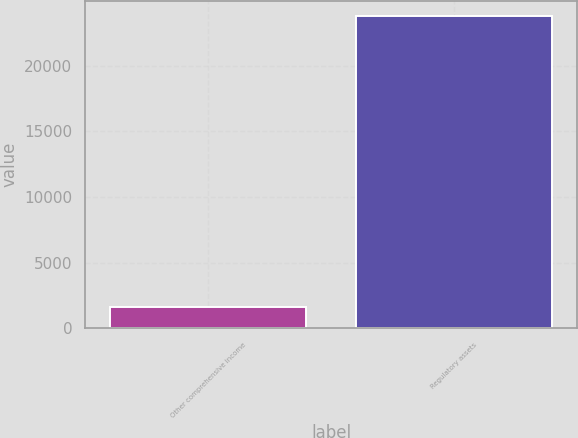Convert chart. <chart><loc_0><loc_0><loc_500><loc_500><bar_chart><fcel>Other comprehensive income<fcel>Regulatory assets<nl><fcel>1639<fcel>23768<nl></chart> 